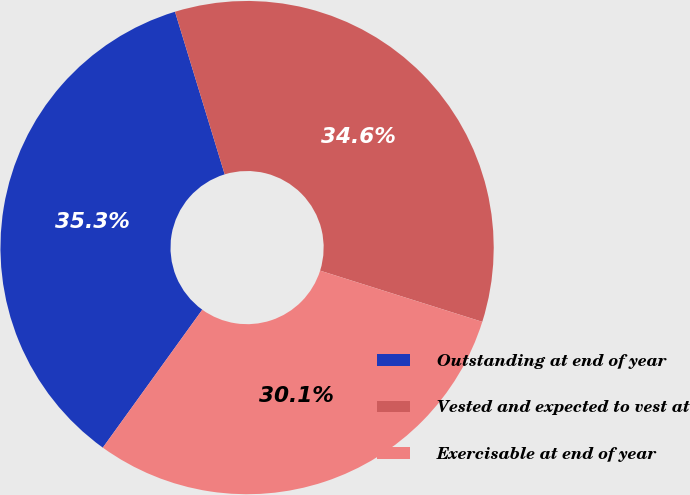Convert chart. <chart><loc_0><loc_0><loc_500><loc_500><pie_chart><fcel>Outstanding at end of year<fcel>Vested and expected to vest at<fcel>Exercisable at end of year<nl><fcel>35.34%<fcel>34.59%<fcel>30.08%<nl></chart> 